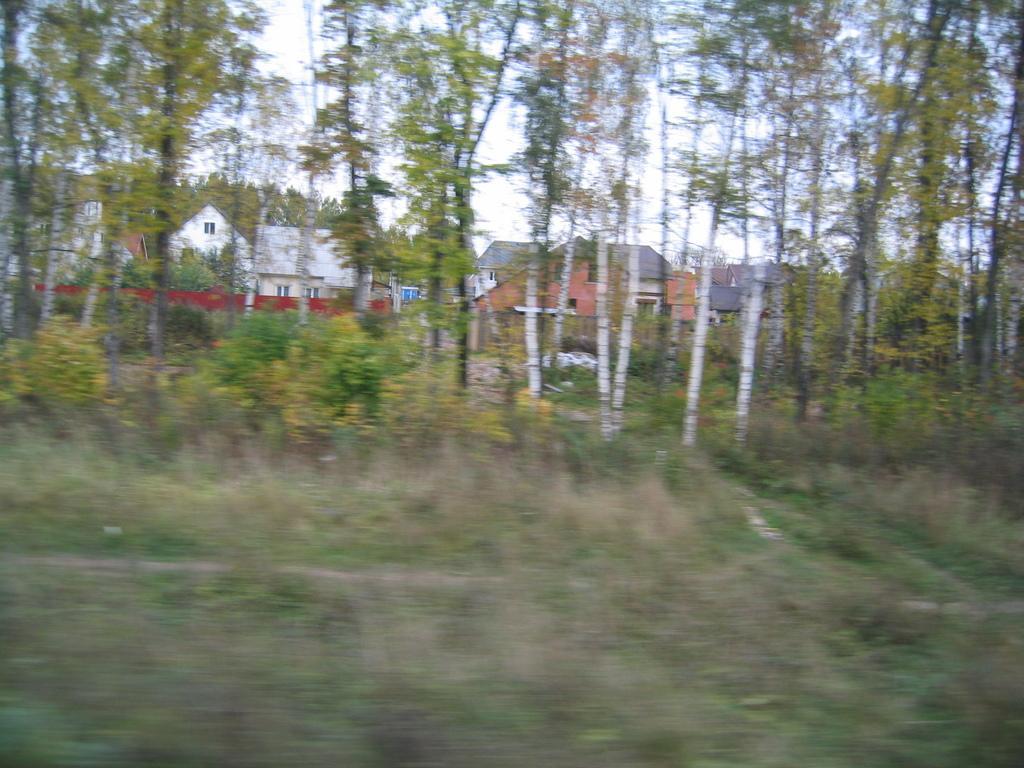Describe this image in one or two sentences. As we can see in the image there are plants, trees, houses and sky. 